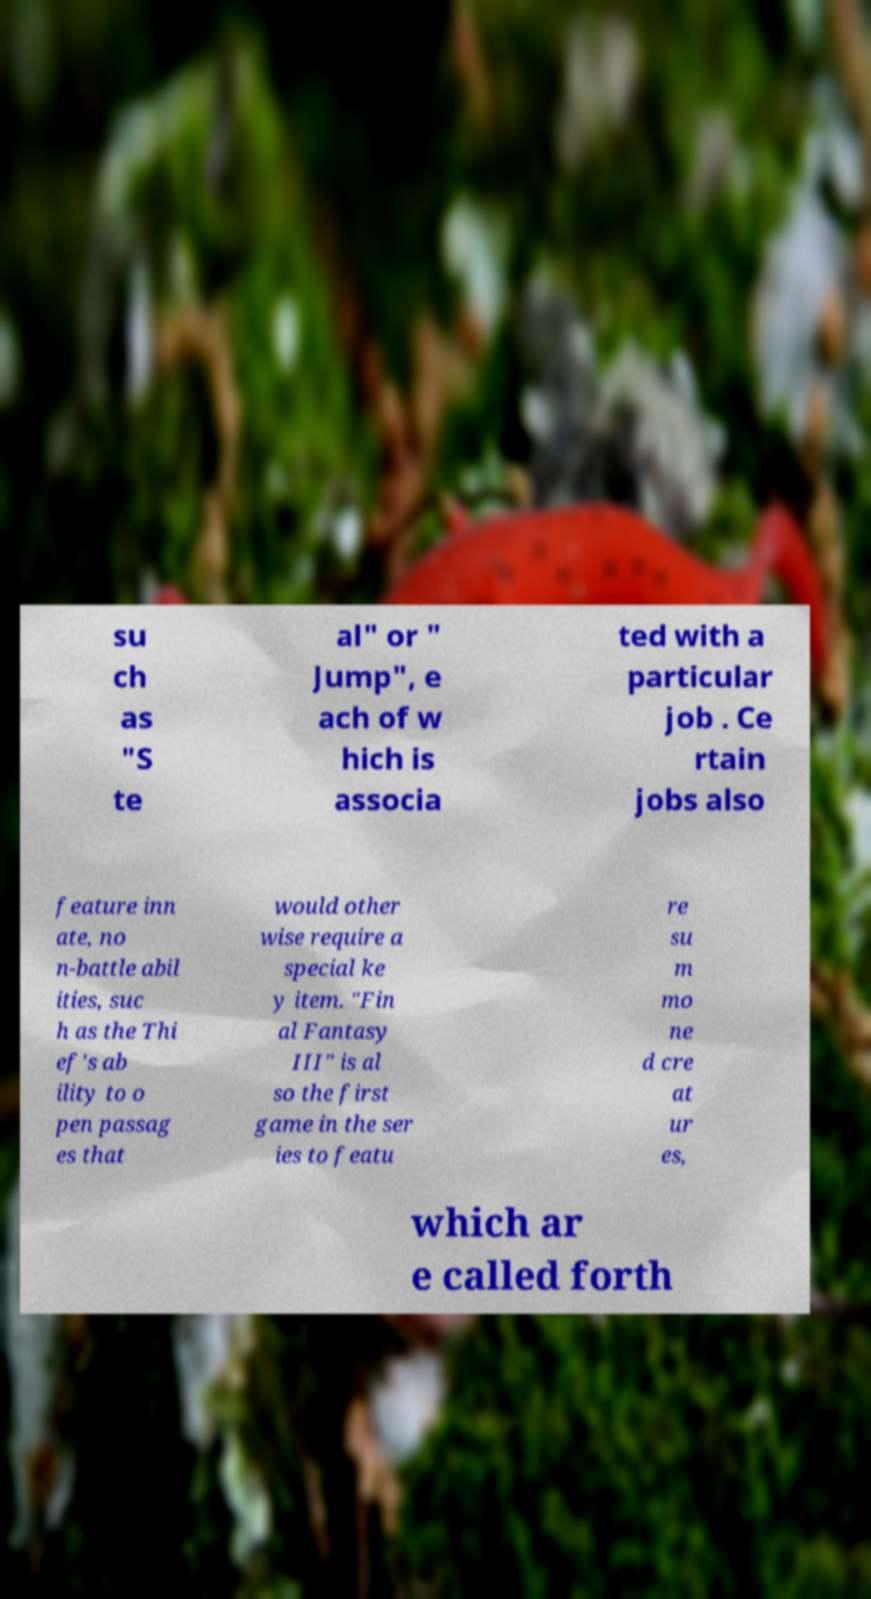Could you extract and type out the text from this image? su ch as "S te al" or " Jump", e ach of w hich is associa ted with a particular job . Ce rtain jobs also feature inn ate, no n-battle abil ities, suc h as the Thi ef's ab ility to o pen passag es that would other wise require a special ke y item. "Fin al Fantasy III" is al so the first game in the ser ies to featu re su m mo ne d cre at ur es, which ar e called forth 